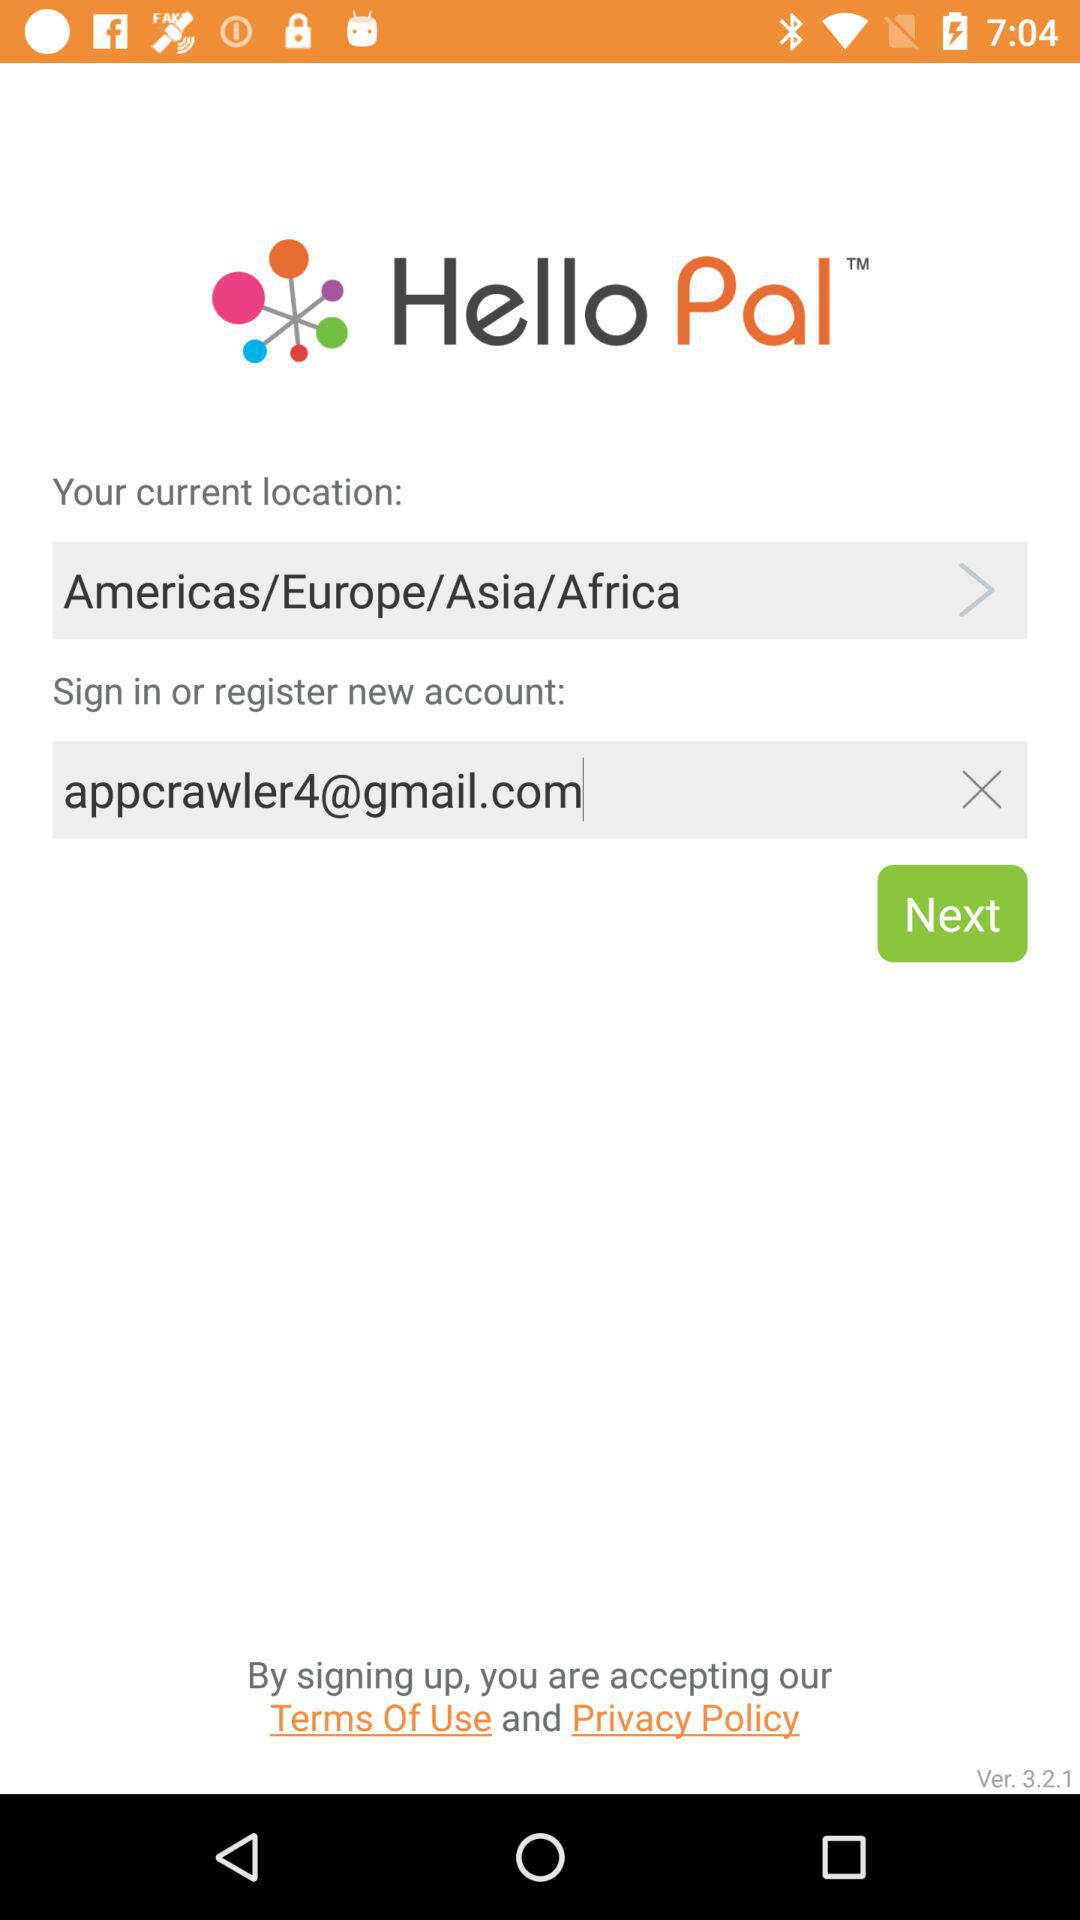What is the email address? The email address is appcrawler4@gmail.com. 